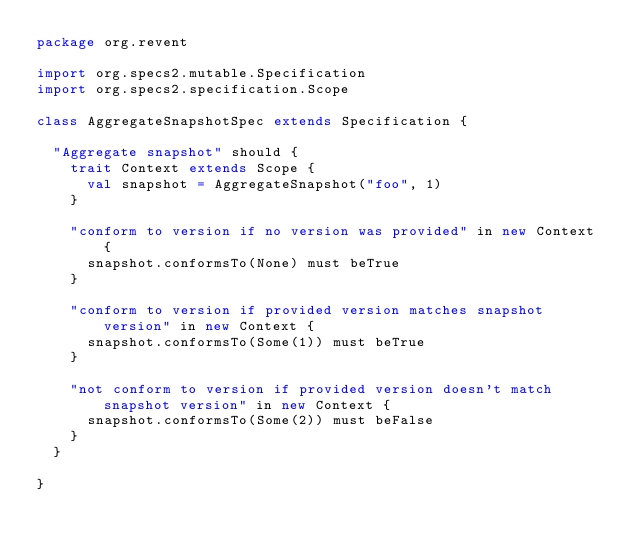<code> <loc_0><loc_0><loc_500><loc_500><_Scala_>package org.revent

import org.specs2.mutable.Specification
import org.specs2.specification.Scope

class AggregateSnapshotSpec extends Specification {

  "Aggregate snapshot" should {
    trait Context extends Scope {
      val snapshot = AggregateSnapshot("foo", 1)
    }

    "conform to version if no version was provided" in new Context {
      snapshot.conformsTo(None) must beTrue
    }

    "conform to version if provided version matches snapshot version" in new Context {
      snapshot.conformsTo(Some(1)) must beTrue
    }

    "not conform to version if provided version doesn't match snapshot version" in new Context {
      snapshot.conformsTo(Some(2)) must beFalse
    }
  }

}
</code> 